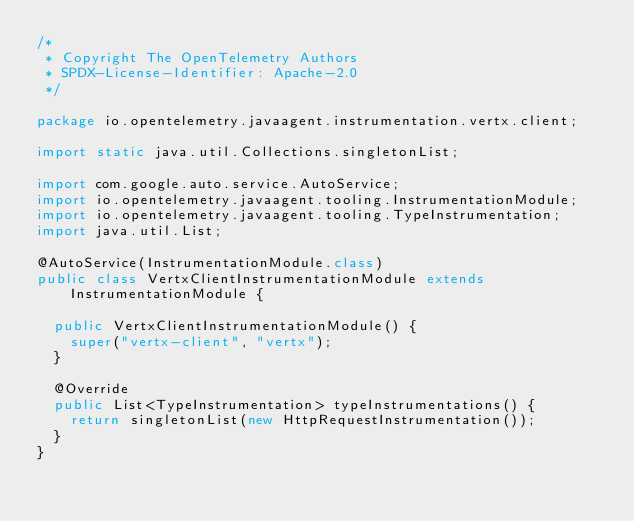Convert code to text. <code><loc_0><loc_0><loc_500><loc_500><_Java_>/*
 * Copyright The OpenTelemetry Authors
 * SPDX-License-Identifier: Apache-2.0
 */

package io.opentelemetry.javaagent.instrumentation.vertx.client;

import static java.util.Collections.singletonList;

import com.google.auto.service.AutoService;
import io.opentelemetry.javaagent.tooling.InstrumentationModule;
import io.opentelemetry.javaagent.tooling.TypeInstrumentation;
import java.util.List;

@AutoService(InstrumentationModule.class)
public class VertxClientInstrumentationModule extends InstrumentationModule {

  public VertxClientInstrumentationModule() {
    super("vertx-client", "vertx");
  }

  @Override
  public List<TypeInstrumentation> typeInstrumentations() {
    return singletonList(new HttpRequestInstrumentation());
  }
}
</code> 